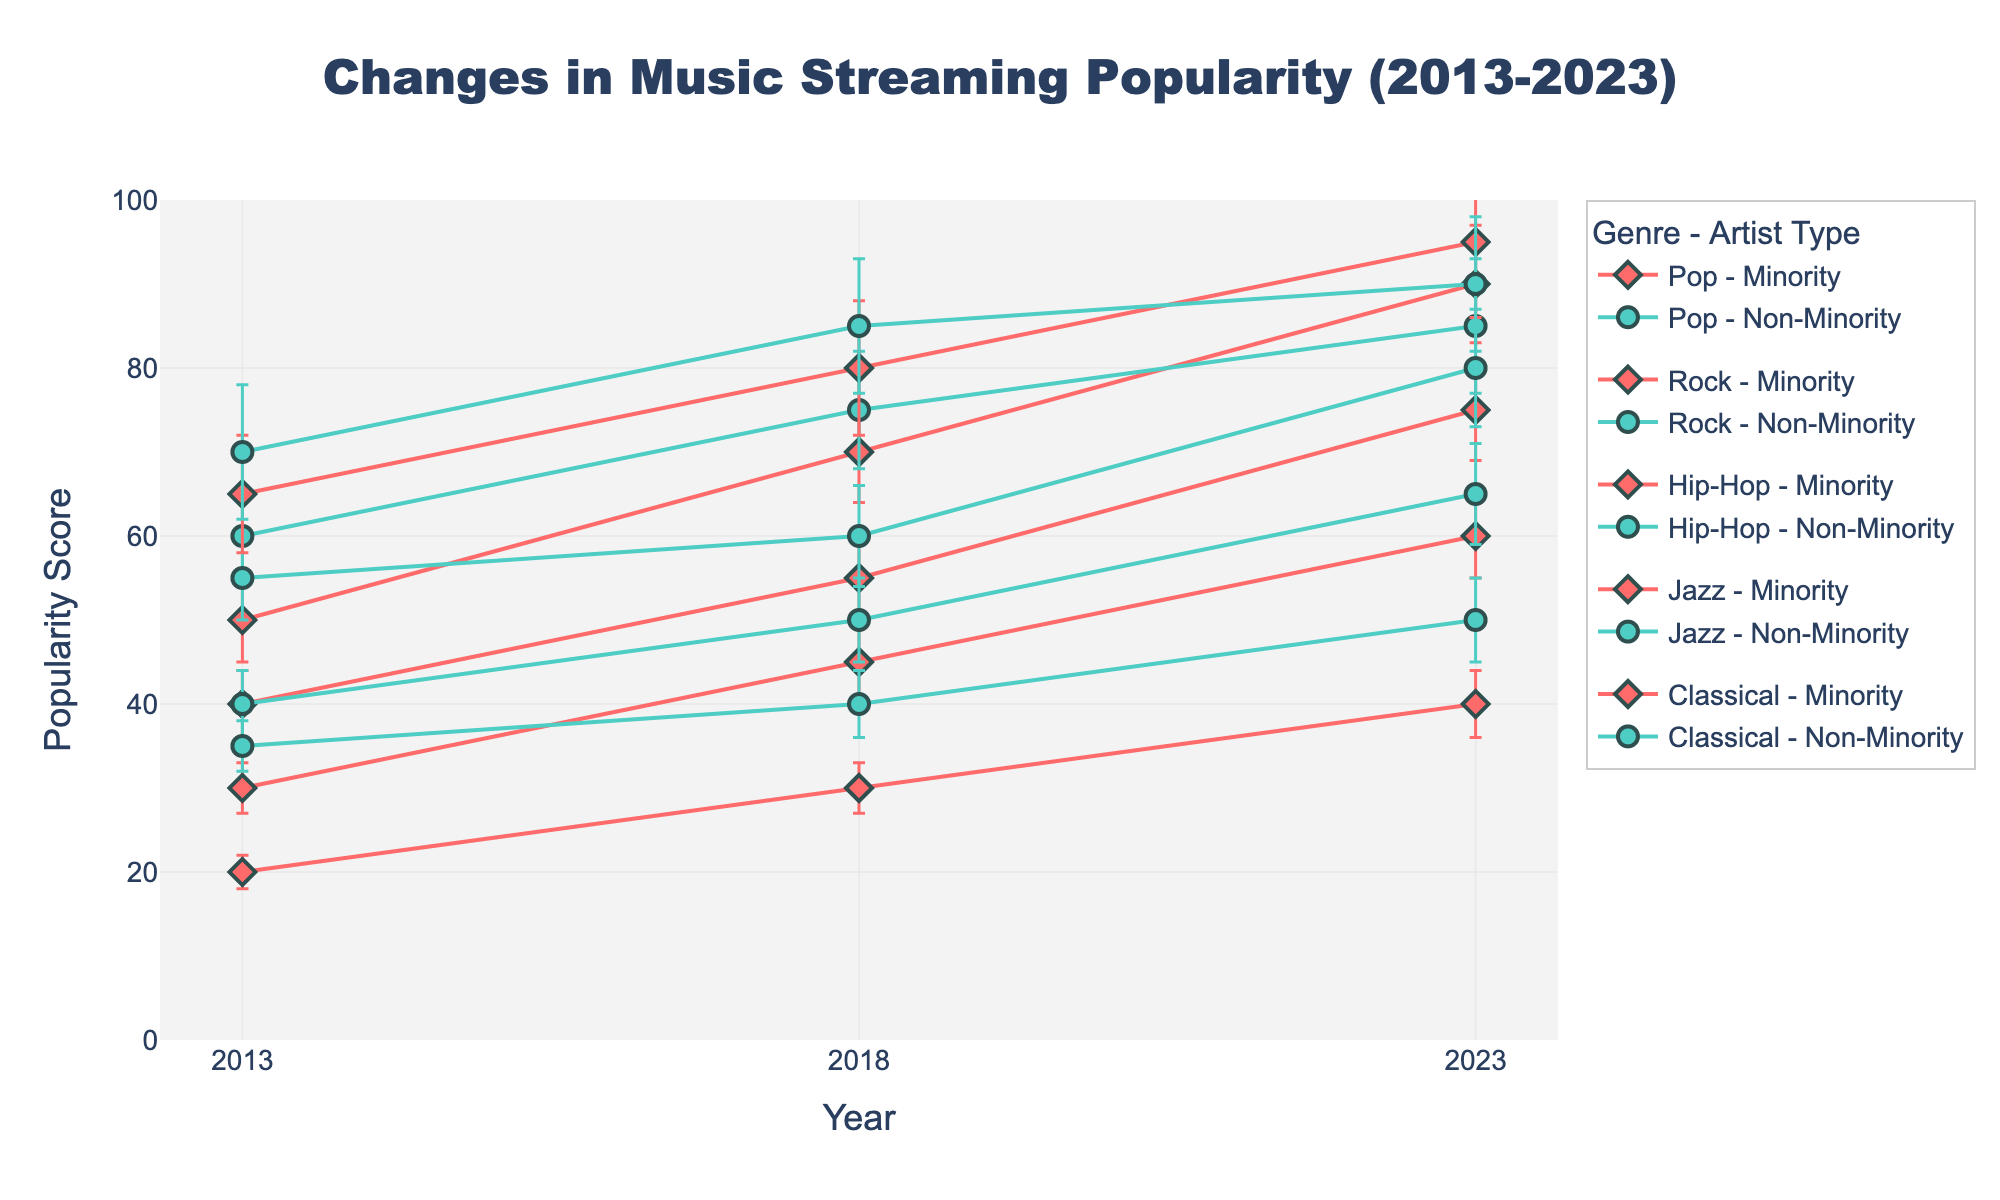What's the title of the figure? The title of the figure is given at the top of the plot, right above the graph area. Reading it directly will give the answer.
Answer: Changes in Music Streaming Popularity (2013-2023) What does the x-axis represent? The x-axis usually represents an independent variable, and here it is clearly labeled.
Answer: Year What does the y-axis represent? The y-axis typically represents a dependent variable, and here it includes a label.
Answer: Popularity Score Which genre shows the highest popularity score for minority artists in 2023? To find the answer, look for the highest point among minority artist data points in 2023; compare the values for all genres.
Answer: Hip-Hop How has the popularity of Classical music for non-minority artists changed from 2013 to 2023? Track the line for Classical music for non-minority artists from 2013 to 2023 and note the changes in popularity score over these years.
Answer: Increased from 35 to 50 What is the difference in popularity scores between minority and non-minority Pop artists in 2023? First, find the popularity scores for both minority and non-minority Pop artists in 2023. Then, subtract the minority score from the non-minority score.
Answer: 5 (90 - 85) Which genre shows the smallest change in popularity for minority artists from 2013 to 2023? Look at the trend lines for each genre for minority artists between 2013 and 2023. The smallest difference between the first and last data points will identify the genre with the smallest change.
Answer: Classical (20 to 40) Compare the 2018 popularity scores for minority and non-minority Jazz artists. Are they closer in value or farther apart compared to the Pop genre in the same year? Identify the 2018 popularity scores for Jazz minority and non-minority artists and calculate the difference; do the same for Pop. Then, compare these differences.
Answer: Jazz scores are closer (5 difference) than Pop (5 difference) Which artist type, minority or non-minority, shows more significant variance in their popularity scores within each genre in 2023? Review the error bars for both types of artists in each genre for 2023. The artist type with larger error bars indicates more significant variance within each genre.
Answer: Minority (generally larger error bars) What's the trend in Hip-Hop popularity for both minority and non-minority artists from 2013 to 2023? Look at the Hip-Hop data points for both minority and non-minority artists across the years 2013, 2018, and 2023. Note the direction (increasing, decreasing, or static) of the lines.
Answer: Increasing for both 